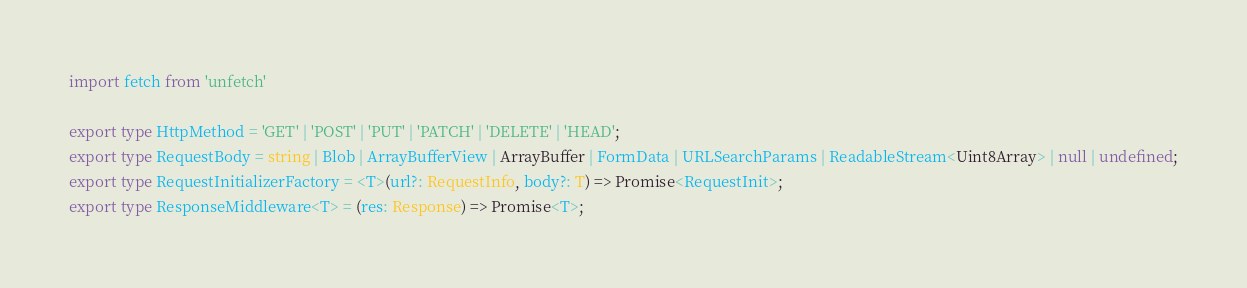Convert code to text. <code><loc_0><loc_0><loc_500><loc_500><_TypeScript_>import fetch from 'unfetch'

export type HttpMethod = 'GET' | 'POST' | 'PUT' | 'PATCH' | 'DELETE' | 'HEAD';
export type RequestBody = string | Blob | ArrayBufferView | ArrayBuffer | FormData | URLSearchParams | ReadableStream<Uint8Array> | null | undefined;
export type RequestInitializerFactory = <T>(url?: RequestInfo, body?: T) => Promise<RequestInit>;
export type ResponseMiddleware<T> = (res: Response) => Promise<T>;</code> 